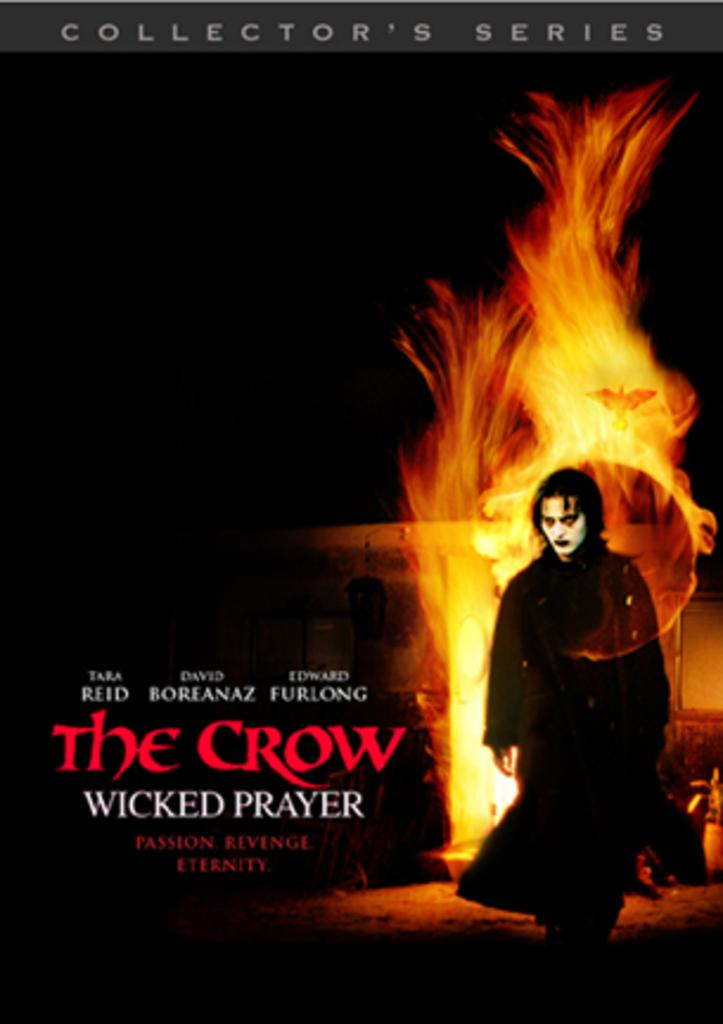<image>
Create a compact narrative representing the image presented. a poster of a book 'the crow wicked prayer' a collector's series 